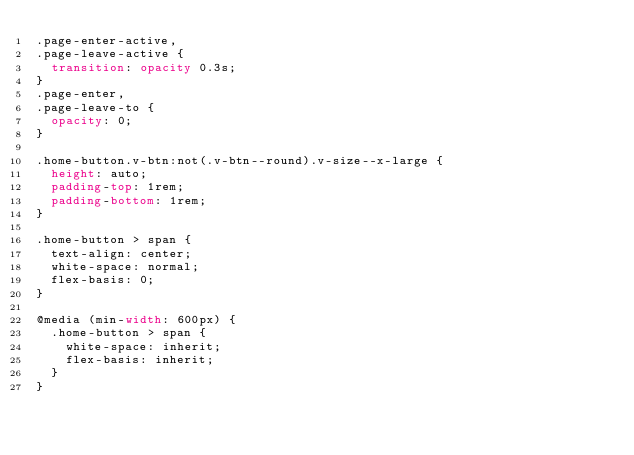<code> <loc_0><loc_0><loc_500><loc_500><_CSS_>.page-enter-active,
.page-leave-active {
  transition: opacity 0.3s;
}
.page-enter,
.page-leave-to {
  opacity: 0;
}

.home-button.v-btn:not(.v-btn--round).v-size--x-large {
  height: auto;
  padding-top: 1rem;
  padding-bottom: 1rem;
}

.home-button > span {
  text-align: center;
  white-space: normal;
  flex-basis: 0;
}

@media (min-width: 600px) {
  .home-button > span {
    white-space: inherit;
    flex-basis: inherit;
  }
}
</code> 